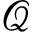<formula> <loc_0><loc_0><loc_500><loc_500>\mathcal { Q }</formula> 